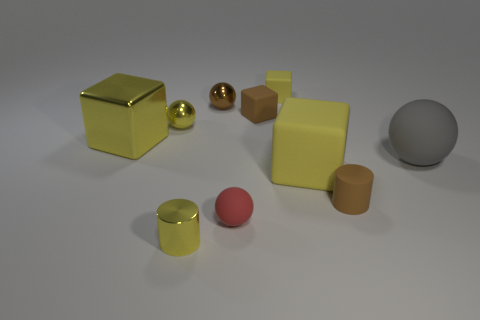How many yellow blocks must be subtracted to get 1 yellow blocks? 2 Subtract all cyan cylinders. How many yellow blocks are left? 3 Subtract all cyan cylinders. Subtract all purple blocks. How many cylinders are left? 2 Subtract all cylinders. How many objects are left? 8 Subtract 0 purple balls. How many objects are left? 10 Subtract all large gray spheres. Subtract all small red balls. How many objects are left? 8 Add 8 small brown metal objects. How many small brown metal objects are left? 9 Add 8 small red rubber balls. How many small red rubber balls exist? 9 